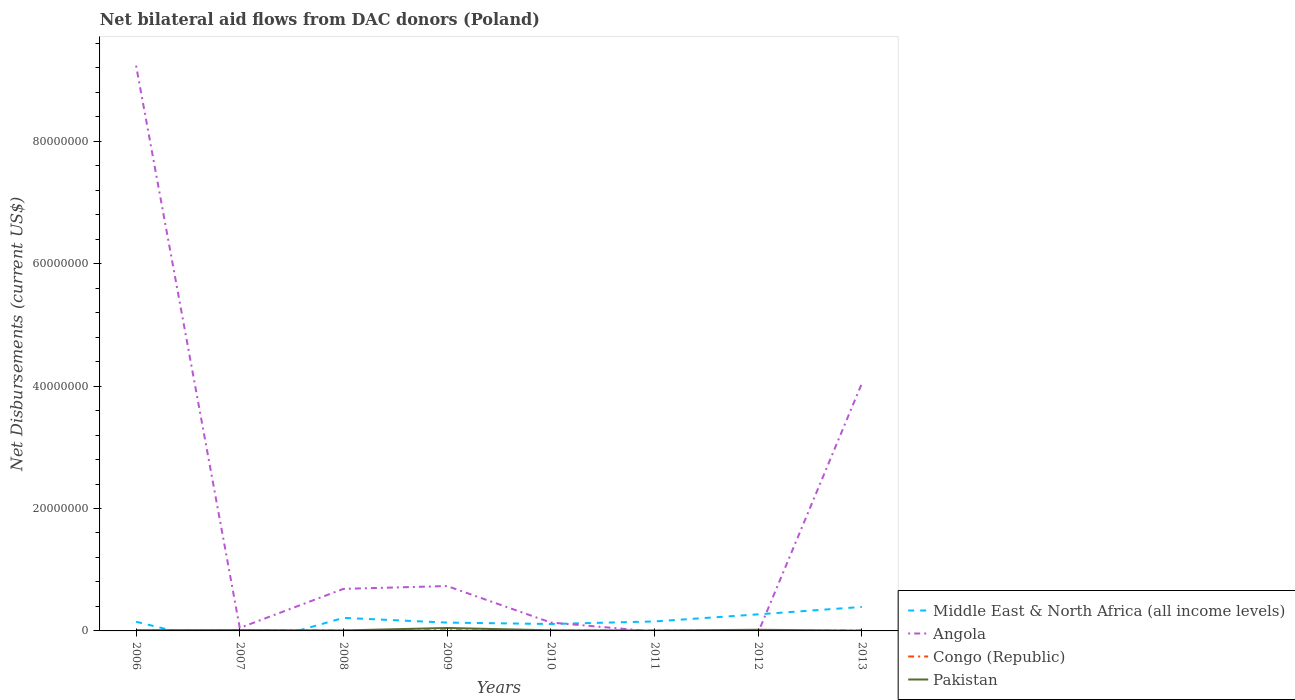What is the total net bilateral aid flows in Pakistan in the graph?
Your response must be concise. 1.00e+05. What is the difference between the highest and the second highest net bilateral aid flows in Middle East & North Africa (all income levels)?
Offer a terse response. 3.92e+06. What is the difference between the highest and the lowest net bilateral aid flows in Middle East & North Africa (all income levels)?
Ensure brevity in your answer.  3. How many lines are there?
Provide a short and direct response. 4. What is the difference between two consecutive major ticks on the Y-axis?
Offer a terse response. 2.00e+07. Are the values on the major ticks of Y-axis written in scientific E-notation?
Make the answer very short. No. Does the graph contain any zero values?
Give a very brief answer. Yes. Does the graph contain grids?
Keep it short and to the point. No. Where does the legend appear in the graph?
Offer a terse response. Bottom right. How are the legend labels stacked?
Offer a terse response. Vertical. What is the title of the graph?
Provide a short and direct response. Net bilateral aid flows from DAC donors (Poland). Does "India" appear as one of the legend labels in the graph?
Keep it short and to the point. No. What is the label or title of the Y-axis?
Your answer should be compact. Net Disbursements (current US$). What is the Net Disbursements (current US$) of Middle East & North Africa (all income levels) in 2006?
Keep it short and to the point. 1.50e+06. What is the Net Disbursements (current US$) of Angola in 2006?
Provide a succinct answer. 9.24e+07. What is the Net Disbursements (current US$) of Congo (Republic) in 2006?
Make the answer very short. 2.00e+04. What is the Net Disbursements (current US$) of Angola in 2007?
Offer a terse response. 4.90e+05. What is the Net Disbursements (current US$) in Pakistan in 2007?
Give a very brief answer. 1.40e+05. What is the Net Disbursements (current US$) in Middle East & North Africa (all income levels) in 2008?
Make the answer very short. 2.13e+06. What is the Net Disbursements (current US$) of Angola in 2008?
Keep it short and to the point. 6.87e+06. What is the Net Disbursements (current US$) of Pakistan in 2008?
Make the answer very short. 8.00e+04. What is the Net Disbursements (current US$) in Middle East & North Africa (all income levels) in 2009?
Offer a terse response. 1.36e+06. What is the Net Disbursements (current US$) of Angola in 2009?
Your response must be concise. 7.33e+06. What is the Net Disbursements (current US$) of Pakistan in 2009?
Offer a terse response. 4.80e+05. What is the Net Disbursements (current US$) of Middle East & North Africa (all income levels) in 2010?
Ensure brevity in your answer.  1.13e+06. What is the Net Disbursements (current US$) of Angola in 2010?
Your answer should be very brief. 1.37e+06. What is the Net Disbursements (current US$) in Pakistan in 2010?
Offer a terse response. 1.00e+05. What is the Net Disbursements (current US$) in Middle East & North Africa (all income levels) in 2011?
Keep it short and to the point. 1.55e+06. What is the Net Disbursements (current US$) in Angola in 2011?
Your answer should be very brief. 0. What is the Net Disbursements (current US$) of Congo (Republic) in 2011?
Offer a very short reply. 5.00e+04. What is the Net Disbursements (current US$) of Middle East & North Africa (all income levels) in 2012?
Keep it short and to the point. 2.71e+06. What is the Net Disbursements (current US$) in Pakistan in 2012?
Ensure brevity in your answer.  1.90e+05. What is the Net Disbursements (current US$) in Middle East & North Africa (all income levels) in 2013?
Offer a very short reply. 3.92e+06. What is the Net Disbursements (current US$) of Angola in 2013?
Make the answer very short. 4.04e+07. What is the Net Disbursements (current US$) in Congo (Republic) in 2013?
Provide a short and direct response. 6.00e+04. What is the Net Disbursements (current US$) in Pakistan in 2013?
Offer a terse response. 4.00e+04. Across all years, what is the maximum Net Disbursements (current US$) in Middle East & North Africa (all income levels)?
Your answer should be compact. 3.92e+06. Across all years, what is the maximum Net Disbursements (current US$) in Angola?
Ensure brevity in your answer.  9.24e+07. Across all years, what is the minimum Net Disbursements (current US$) in Pakistan?
Your answer should be very brief. 4.00e+04. What is the total Net Disbursements (current US$) of Middle East & North Africa (all income levels) in the graph?
Ensure brevity in your answer.  1.43e+07. What is the total Net Disbursements (current US$) of Angola in the graph?
Make the answer very short. 1.49e+08. What is the total Net Disbursements (current US$) in Pakistan in the graph?
Keep it short and to the point. 1.21e+06. What is the difference between the Net Disbursements (current US$) in Angola in 2006 and that in 2007?
Provide a succinct answer. 9.19e+07. What is the difference between the Net Disbursements (current US$) in Congo (Republic) in 2006 and that in 2007?
Provide a short and direct response. -9.00e+04. What is the difference between the Net Disbursements (current US$) in Middle East & North Africa (all income levels) in 2006 and that in 2008?
Your answer should be very brief. -6.30e+05. What is the difference between the Net Disbursements (current US$) in Angola in 2006 and that in 2008?
Give a very brief answer. 8.55e+07. What is the difference between the Net Disbursements (current US$) of Pakistan in 2006 and that in 2008?
Your response must be concise. 4.00e+04. What is the difference between the Net Disbursements (current US$) of Middle East & North Africa (all income levels) in 2006 and that in 2009?
Ensure brevity in your answer.  1.40e+05. What is the difference between the Net Disbursements (current US$) in Angola in 2006 and that in 2009?
Ensure brevity in your answer.  8.50e+07. What is the difference between the Net Disbursements (current US$) of Pakistan in 2006 and that in 2009?
Your answer should be compact. -3.60e+05. What is the difference between the Net Disbursements (current US$) in Angola in 2006 and that in 2010?
Make the answer very short. 9.10e+07. What is the difference between the Net Disbursements (current US$) in Pakistan in 2006 and that in 2010?
Provide a succinct answer. 2.00e+04. What is the difference between the Net Disbursements (current US$) of Middle East & North Africa (all income levels) in 2006 and that in 2011?
Provide a short and direct response. -5.00e+04. What is the difference between the Net Disbursements (current US$) of Congo (Republic) in 2006 and that in 2011?
Give a very brief answer. -3.00e+04. What is the difference between the Net Disbursements (current US$) of Pakistan in 2006 and that in 2011?
Your response must be concise. 6.00e+04. What is the difference between the Net Disbursements (current US$) in Middle East & North Africa (all income levels) in 2006 and that in 2012?
Offer a terse response. -1.21e+06. What is the difference between the Net Disbursements (current US$) in Pakistan in 2006 and that in 2012?
Give a very brief answer. -7.00e+04. What is the difference between the Net Disbursements (current US$) of Middle East & North Africa (all income levels) in 2006 and that in 2013?
Ensure brevity in your answer.  -2.42e+06. What is the difference between the Net Disbursements (current US$) of Angola in 2006 and that in 2013?
Make the answer very short. 5.19e+07. What is the difference between the Net Disbursements (current US$) in Congo (Republic) in 2006 and that in 2013?
Your response must be concise. -4.00e+04. What is the difference between the Net Disbursements (current US$) of Angola in 2007 and that in 2008?
Make the answer very short. -6.38e+06. What is the difference between the Net Disbursements (current US$) in Pakistan in 2007 and that in 2008?
Offer a very short reply. 6.00e+04. What is the difference between the Net Disbursements (current US$) in Angola in 2007 and that in 2009?
Make the answer very short. -6.84e+06. What is the difference between the Net Disbursements (current US$) of Pakistan in 2007 and that in 2009?
Ensure brevity in your answer.  -3.40e+05. What is the difference between the Net Disbursements (current US$) in Angola in 2007 and that in 2010?
Make the answer very short. -8.80e+05. What is the difference between the Net Disbursements (current US$) in Pakistan in 2007 and that in 2011?
Make the answer very short. 8.00e+04. What is the difference between the Net Disbursements (current US$) in Congo (Republic) in 2007 and that in 2012?
Give a very brief answer. 9.00e+04. What is the difference between the Net Disbursements (current US$) of Angola in 2007 and that in 2013?
Ensure brevity in your answer.  -4.00e+07. What is the difference between the Net Disbursements (current US$) in Congo (Republic) in 2007 and that in 2013?
Offer a very short reply. 5.00e+04. What is the difference between the Net Disbursements (current US$) of Middle East & North Africa (all income levels) in 2008 and that in 2009?
Ensure brevity in your answer.  7.70e+05. What is the difference between the Net Disbursements (current US$) of Angola in 2008 and that in 2009?
Offer a very short reply. -4.60e+05. What is the difference between the Net Disbursements (current US$) of Congo (Republic) in 2008 and that in 2009?
Provide a short and direct response. -6.00e+04. What is the difference between the Net Disbursements (current US$) of Pakistan in 2008 and that in 2009?
Provide a succinct answer. -4.00e+05. What is the difference between the Net Disbursements (current US$) of Middle East & North Africa (all income levels) in 2008 and that in 2010?
Your answer should be compact. 1.00e+06. What is the difference between the Net Disbursements (current US$) in Angola in 2008 and that in 2010?
Give a very brief answer. 5.50e+06. What is the difference between the Net Disbursements (current US$) in Congo (Republic) in 2008 and that in 2010?
Give a very brief answer. 10000. What is the difference between the Net Disbursements (current US$) in Middle East & North Africa (all income levels) in 2008 and that in 2011?
Your answer should be compact. 5.80e+05. What is the difference between the Net Disbursements (current US$) in Middle East & North Africa (all income levels) in 2008 and that in 2012?
Ensure brevity in your answer.  -5.80e+05. What is the difference between the Net Disbursements (current US$) in Congo (Republic) in 2008 and that in 2012?
Ensure brevity in your answer.  3.00e+04. What is the difference between the Net Disbursements (current US$) of Pakistan in 2008 and that in 2012?
Make the answer very short. -1.10e+05. What is the difference between the Net Disbursements (current US$) of Middle East & North Africa (all income levels) in 2008 and that in 2013?
Offer a very short reply. -1.79e+06. What is the difference between the Net Disbursements (current US$) in Angola in 2008 and that in 2013?
Give a very brief answer. -3.36e+07. What is the difference between the Net Disbursements (current US$) of Middle East & North Africa (all income levels) in 2009 and that in 2010?
Your answer should be compact. 2.30e+05. What is the difference between the Net Disbursements (current US$) of Angola in 2009 and that in 2010?
Offer a terse response. 5.96e+06. What is the difference between the Net Disbursements (current US$) in Pakistan in 2009 and that in 2010?
Provide a succinct answer. 3.80e+05. What is the difference between the Net Disbursements (current US$) of Middle East & North Africa (all income levels) in 2009 and that in 2012?
Offer a very short reply. -1.35e+06. What is the difference between the Net Disbursements (current US$) of Congo (Republic) in 2009 and that in 2012?
Your answer should be very brief. 9.00e+04. What is the difference between the Net Disbursements (current US$) of Pakistan in 2009 and that in 2012?
Make the answer very short. 2.90e+05. What is the difference between the Net Disbursements (current US$) in Middle East & North Africa (all income levels) in 2009 and that in 2013?
Your response must be concise. -2.56e+06. What is the difference between the Net Disbursements (current US$) in Angola in 2009 and that in 2013?
Give a very brief answer. -3.31e+07. What is the difference between the Net Disbursements (current US$) of Pakistan in 2009 and that in 2013?
Provide a short and direct response. 4.40e+05. What is the difference between the Net Disbursements (current US$) in Middle East & North Africa (all income levels) in 2010 and that in 2011?
Provide a succinct answer. -4.20e+05. What is the difference between the Net Disbursements (current US$) of Congo (Republic) in 2010 and that in 2011?
Provide a short and direct response. -10000. What is the difference between the Net Disbursements (current US$) of Pakistan in 2010 and that in 2011?
Offer a very short reply. 4.00e+04. What is the difference between the Net Disbursements (current US$) of Middle East & North Africa (all income levels) in 2010 and that in 2012?
Offer a terse response. -1.58e+06. What is the difference between the Net Disbursements (current US$) in Congo (Republic) in 2010 and that in 2012?
Make the answer very short. 2.00e+04. What is the difference between the Net Disbursements (current US$) of Pakistan in 2010 and that in 2012?
Provide a short and direct response. -9.00e+04. What is the difference between the Net Disbursements (current US$) of Middle East & North Africa (all income levels) in 2010 and that in 2013?
Give a very brief answer. -2.79e+06. What is the difference between the Net Disbursements (current US$) in Angola in 2010 and that in 2013?
Offer a terse response. -3.91e+07. What is the difference between the Net Disbursements (current US$) of Congo (Republic) in 2010 and that in 2013?
Your answer should be very brief. -2.00e+04. What is the difference between the Net Disbursements (current US$) of Pakistan in 2010 and that in 2013?
Your answer should be compact. 6.00e+04. What is the difference between the Net Disbursements (current US$) in Middle East & North Africa (all income levels) in 2011 and that in 2012?
Your answer should be compact. -1.16e+06. What is the difference between the Net Disbursements (current US$) of Congo (Republic) in 2011 and that in 2012?
Your answer should be compact. 3.00e+04. What is the difference between the Net Disbursements (current US$) of Pakistan in 2011 and that in 2012?
Offer a very short reply. -1.30e+05. What is the difference between the Net Disbursements (current US$) of Middle East & North Africa (all income levels) in 2011 and that in 2013?
Give a very brief answer. -2.37e+06. What is the difference between the Net Disbursements (current US$) in Pakistan in 2011 and that in 2013?
Provide a succinct answer. 2.00e+04. What is the difference between the Net Disbursements (current US$) in Middle East & North Africa (all income levels) in 2012 and that in 2013?
Your answer should be very brief. -1.21e+06. What is the difference between the Net Disbursements (current US$) in Congo (Republic) in 2012 and that in 2013?
Your answer should be very brief. -4.00e+04. What is the difference between the Net Disbursements (current US$) of Middle East & North Africa (all income levels) in 2006 and the Net Disbursements (current US$) of Angola in 2007?
Provide a succinct answer. 1.01e+06. What is the difference between the Net Disbursements (current US$) of Middle East & North Africa (all income levels) in 2006 and the Net Disbursements (current US$) of Congo (Republic) in 2007?
Provide a short and direct response. 1.39e+06. What is the difference between the Net Disbursements (current US$) of Middle East & North Africa (all income levels) in 2006 and the Net Disbursements (current US$) of Pakistan in 2007?
Your answer should be compact. 1.36e+06. What is the difference between the Net Disbursements (current US$) of Angola in 2006 and the Net Disbursements (current US$) of Congo (Republic) in 2007?
Your answer should be compact. 9.22e+07. What is the difference between the Net Disbursements (current US$) in Angola in 2006 and the Net Disbursements (current US$) in Pakistan in 2007?
Your response must be concise. 9.22e+07. What is the difference between the Net Disbursements (current US$) in Congo (Republic) in 2006 and the Net Disbursements (current US$) in Pakistan in 2007?
Your answer should be compact. -1.20e+05. What is the difference between the Net Disbursements (current US$) of Middle East & North Africa (all income levels) in 2006 and the Net Disbursements (current US$) of Angola in 2008?
Your response must be concise. -5.37e+06. What is the difference between the Net Disbursements (current US$) in Middle East & North Africa (all income levels) in 2006 and the Net Disbursements (current US$) in Congo (Republic) in 2008?
Your answer should be very brief. 1.45e+06. What is the difference between the Net Disbursements (current US$) in Middle East & North Africa (all income levels) in 2006 and the Net Disbursements (current US$) in Pakistan in 2008?
Your response must be concise. 1.42e+06. What is the difference between the Net Disbursements (current US$) in Angola in 2006 and the Net Disbursements (current US$) in Congo (Republic) in 2008?
Provide a succinct answer. 9.23e+07. What is the difference between the Net Disbursements (current US$) of Angola in 2006 and the Net Disbursements (current US$) of Pakistan in 2008?
Your response must be concise. 9.23e+07. What is the difference between the Net Disbursements (current US$) in Middle East & North Africa (all income levels) in 2006 and the Net Disbursements (current US$) in Angola in 2009?
Your answer should be compact. -5.83e+06. What is the difference between the Net Disbursements (current US$) in Middle East & North Africa (all income levels) in 2006 and the Net Disbursements (current US$) in Congo (Republic) in 2009?
Offer a terse response. 1.39e+06. What is the difference between the Net Disbursements (current US$) in Middle East & North Africa (all income levels) in 2006 and the Net Disbursements (current US$) in Pakistan in 2009?
Provide a succinct answer. 1.02e+06. What is the difference between the Net Disbursements (current US$) of Angola in 2006 and the Net Disbursements (current US$) of Congo (Republic) in 2009?
Ensure brevity in your answer.  9.22e+07. What is the difference between the Net Disbursements (current US$) of Angola in 2006 and the Net Disbursements (current US$) of Pakistan in 2009?
Keep it short and to the point. 9.19e+07. What is the difference between the Net Disbursements (current US$) in Congo (Republic) in 2006 and the Net Disbursements (current US$) in Pakistan in 2009?
Offer a terse response. -4.60e+05. What is the difference between the Net Disbursements (current US$) of Middle East & North Africa (all income levels) in 2006 and the Net Disbursements (current US$) of Angola in 2010?
Your answer should be very brief. 1.30e+05. What is the difference between the Net Disbursements (current US$) of Middle East & North Africa (all income levels) in 2006 and the Net Disbursements (current US$) of Congo (Republic) in 2010?
Your response must be concise. 1.46e+06. What is the difference between the Net Disbursements (current US$) of Middle East & North Africa (all income levels) in 2006 and the Net Disbursements (current US$) of Pakistan in 2010?
Your response must be concise. 1.40e+06. What is the difference between the Net Disbursements (current US$) of Angola in 2006 and the Net Disbursements (current US$) of Congo (Republic) in 2010?
Provide a short and direct response. 9.23e+07. What is the difference between the Net Disbursements (current US$) of Angola in 2006 and the Net Disbursements (current US$) of Pakistan in 2010?
Keep it short and to the point. 9.22e+07. What is the difference between the Net Disbursements (current US$) of Congo (Republic) in 2006 and the Net Disbursements (current US$) of Pakistan in 2010?
Make the answer very short. -8.00e+04. What is the difference between the Net Disbursements (current US$) of Middle East & North Africa (all income levels) in 2006 and the Net Disbursements (current US$) of Congo (Republic) in 2011?
Offer a very short reply. 1.45e+06. What is the difference between the Net Disbursements (current US$) of Middle East & North Africa (all income levels) in 2006 and the Net Disbursements (current US$) of Pakistan in 2011?
Ensure brevity in your answer.  1.44e+06. What is the difference between the Net Disbursements (current US$) in Angola in 2006 and the Net Disbursements (current US$) in Congo (Republic) in 2011?
Your answer should be compact. 9.23e+07. What is the difference between the Net Disbursements (current US$) of Angola in 2006 and the Net Disbursements (current US$) of Pakistan in 2011?
Provide a short and direct response. 9.23e+07. What is the difference between the Net Disbursements (current US$) of Congo (Republic) in 2006 and the Net Disbursements (current US$) of Pakistan in 2011?
Keep it short and to the point. -4.00e+04. What is the difference between the Net Disbursements (current US$) in Middle East & North Africa (all income levels) in 2006 and the Net Disbursements (current US$) in Congo (Republic) in 2012?
Offer a very short reply. 1.48e+06. What is the difference between the Net Disbursements (current US$) in Middle East & North Africa (all income levels) in 2006 and the Net Disbursements (current US$) in Pakistan in 2012?
Keep it short and to the point. 1.31e+06. What is the difference between the Net Disbursements (current US$) of Angola in 2006 and the Net Disbursements (current US$) of Congo (Republic) in 2012?
Your answer should be compact. 9.23e+07. What is the difference between the Net Disbursements (current US$) in Angola in 2006 and the Net Disbursements (current US$) in Pakistan in 2012?
Ensure brevity in your answer.  9.22e+07. What is the difference between the Net Disbursements (current US$) of Middle East & North Africa (all income levels) in 2006 and the Net Disbursements (current US$) of Angola in 2013?
Keep it short and to the point. -3.89e+07. What is the difference between the Net Disbursements (current US$) in Middle East & North Africa (all income levels) in 2006 and the Net Disbursements (current US$) in Congo (Republic) in 2013?
Your response must be concise. 1.44e+06. What is the difference between the Net Disbursements (current US$) of Middle East & North Africa (all income levels) in 2006 and the Net Disbursements (current US$) of Pakistan in 2013?
Your response must be concise. 1.46e+06. What is the difference between the Net Disbursements (current US$) in Angola in 2006 and the Net Disbursements (current US$) in Congo (Republic) in 2013?
Provide a succinct answer. 9.23e+07. What is the difference between the Net Disbursements (current US$) of Angola in 2006 and the Net Disbursements (current US$) of Pakistan in 2013?
Give a very brief answer. 9.23e+07. What is the difference between the Net Disbursements (current US$) in Angola in 2007 and the Net Disbursements (current US$) in Congo (Republic) in 2008?
Your response must be concise. 4.40e+05. What is the difference between the Net Disbursements (current US$) of Angola in 2007 and the Net Disbursements (current US$) of Congo (Republic) in 2009?
Your answer should be compact. 3.80e+05. What is the difference between the Net Disbursements (current US$) in Angola in 2007 and the Net Disbursements (current US$) in Pakistan in 2009?
Provide a succinct answer. 10000. What is the difference between the Net Disbursements (current US$) in Congo (Republic) in 2007 and the Net Disbursements (current US$) in Pakistan in 2009?
Keep it short and to the point. -3.70e+05. What is the difference between the Net Disbursements (current US$) in Congo (Republic) in 2007 and the Net Disbursements (current US$) in Pakistan in 2010?
Your response must be concise. 10000. What is the difference between the Net Disbursements (current US$) in Congo (Republic) in 2007 and the Net Disbursements (current US$) in Pakistan in 2011?
Provide a succinct answer. 5.00e+04. What is the difference between the Net Disbursements (current US$) in Angola in 2007 and the Net Disbursements (current US$) in Congo (Republic) in 2012?
Make the answer very short. 4.70e+05. What is the difference between the Net Disbursements (current US$) in Angola in 2007 and the Net Disbursements (current US$) in Pakistan in 2012?
Keep it short and to the point. 3.00e+05. What is the difference between the Net Disbursements (current US$) in Angola in 2007 and the Net Disbursements (current US$) in Congo (Republic) in 2013?
Your response must be concise. 4.30e+05. What is the difference between the Net Disbursements (current US$) of Middle East & North Africa (all income levels) in 2008 and the Net Disbursements (current US$) of Angola in 2009?
Your answer should be compact. -5.20e+06. What is the difference between the Net Disbursements (current US$) of Middle East & North Africa (all income levels) in 2008 and the Net Disbursements (current US$) of Congo (Republic) in 2009?
Your response must be concise. 2.02e+06. What is the difference between the Net Disbursements (current US$) of Middle East & North Africa (all income levels) in 2008 and the Net Disbursements (current US$) of Pakistan in 2009?
Offer a terse response. 1.65e+06. What is the difference between the Net Disbursements (current US$) in Angola in 2008 and the Net Disbursements (current US$) in Congo (Republic) in 2009?
Give a very brief answer. 6.76e+06. What is the difference between the Net Disbursements (current US$) in Angola in 2008 and the Net Disbursements (current US$) in Pakistan in 2009?
Offer a terse response. 6.39e+06. What is the difference between the Net Disbursements (current US$) in Congo (Republic) in 2008 and the Net Disbursements (current US$) in Pakistan in 2009?
Your answer should be compact. -4.30e+05. What is the difference between the Net Disbursements (current US$) in Middle East & North Africa (all income levels) in 2008 and the Net Disbursements (current US$) in Angola in 2010?
Your answer should be very brief. 7.60e+05. What is the difference between the Net Disbursements (current US$) in Middle East & North Africa (all income levels) in 2008 and the Net Disbursements (current US$) in Congo (Republic) in 2010?
Offer a terse response. 2.09e+06. What is the difference between the Net Disbursements (current US$) in Middle East & North Africa (all income levels) in 2008 and the Net Disbursements (current US$) in Pakistan in 2010?
Make the answer very short. 2.03e+06. What is the difference between the Net Disbursements (current US$) of Angola in 2008 and the Net Disbursements (current US$) of Congo (Republic) in 2010?
Your response must be concise. 6.83e+06. What is the difference between the Net Disbursements (current US$) in Angola in 2008 and the Net Disbursements (current US$) in Pakistan in 2010?
Your response must be concise. 6.77e+06. What is the difference between the Net Disbursements (current US$) of Middle East & North Africa (all income levels) in 2008 and the Net Disbursements (current US$) of Congo (Republic) in 2011?
Make the answer very short. 2.08e+06. What is the difference between the Net Disbursements (current US$) of Middle East & North Africa (all income levels) in 2008 and the Net Disbursements (current US$) of Pakistan in 2011?
Offer a terse response. 2.07e+06. What is the difference between the Net Disbursements (current US$) of Angola in 2008 and the Net Disbursements (current US$) of Congo (Republic) in 2011?
Give a very brief answer. 6.82e+06. What is the difference between the Net Disbursements (current US$) of Angola in 2008 and the Net Disbursements (current US$) of Pakistan in 2011?
Offer a very short reply. 6.81e+06. What is the difference between the Net Disbursements (current US$) in Middle East & North Africa (all income levels) in 2008 and the Net Disbursements (current US$) in Congo (Republic) in 2012?
Keep it short and to the point. 2.11e+06. What is the difference between the Net Disbursements (current US$) in Middle East & North Africa (all income levels) in 2008 and the Net Disbursements (current US$) in Pakistan in 2012?
Offer a terse response. 1.94e+06. What is the difference between the Net Disbursements (current US$) of Angola in 2008 and the Net Disbursements (current US$) of Congo (Republic) in 2012?
Your answer should be very brief. 6.85e+06. What is the difference between the Net Disbursements (current US$) in Angola in 2008 and the Net Disbursements (current US$) in Pakistan in 2012?
Provide a succinct answer. 6.68e+06. What is the difference between the Net Disbursements (current US$) in Middle East & North Africa (all income levels) in 2008 and the Net Disbursements (current US$) in Angola in 2013?
Make the answer very short. -3.83e+07. What is the difference between the Net Disbursements (current US$) of Middle East & North Africa (all income levels) in 2008 and the Net Disbursements (current US$) of Congo (Republic) in 2013?
Make the answer very short. 2.07e+06. What is the difference between the Net Disbursements (current US$) of Middle East & North Africa (all income levels) in 2008 and the Net Disbursements (current US$) of Pakistan in 2013?
Offer a terse response. 2.09e+06. What is the difference between the Net Disbursements (current US$) in Angola in 2008 and the Net Disbursements (current US$) in Congo (Republic) in 2013?
Make the answer very short. 6.81e+06. What is the difference between the Net Disbursements (current US$) of Angola in 2008 and the Net Disbursements (current US$) of Pakistan in 2013?
Provide a succinct answer. 6.83e+06. What is the difference between the Net Disbursements (current US$) in Congo (Republic) in 2008 and the Net Disbursements (current US$) in Pakistan in 2013?
Ensure brevity in your answer.  10000. What is the difference between the Net Disbursements (current US$) of Middle East & North Africa (all income levels) in 2009 and the Net Disbursements (current US$) of Angola in 2010?
Ensure brevity in your answer.  -10000. What is the difference between the Net Disbursements (current US$) of Middle East & North Africa (all income levels) in 2009 and the Net Disbursements (current US$) of Congo (Republic) in 2010?
Provide a short and direct response. 1.32e+06. What is the difference between the Net Disbursements (current US$) in Middle East & North Africa (all income levels) in 2009 and the Net Disbursements (current US$) in Pakistan in 2010?
Offer a terse response. 1.26e+06. What is the difference between the Net Disbursements (current US$) of Angola in 2009 and the Net Disbursements (current US$) of Congo (Republic) in 2010?
Your response must be concise. 7.29e+06. What is the difference between the Net Disbursements (current US$) in Angola in 2009 and the Net Disbursements (current US$) in Pakistan in 2010?
Give a very brief answer. 7.23e+06. What is the difference between the Net Disbursements (current US$) in Congo (Republic) in 2009 and the Net Disbursements (current US$) in Pakistan in 2010?
Keep it short and to the point. 10000. What is the difference between the Net Disbursements (current US$) in Middle East & North Africa (all income levels) in 2009 and the Net Disbursements (current US$) in Congo (Republic) in 2011?
Provide a short and direct response. 1.31e+06. What is the difference between the Net Disbursements (current US$) of Middle East & North Africa (all income levels) in 2009 and the Net Disbursements (current US$) of Pakistan in 2011?
Make the answer very short. 1.30e+06. What is the difference between the Net Disbursements (current US$) in Angola in 2009 and the Net Disbursements (current US$) in Congo (Republic) in 2011?
Your answer should be very brief. 7.28e+06. What is the difference between the Net Disbursements (current US$) of Angola in 2009 and the Net Disbursements (current US$) of Pakistan in 2011?
Keep it short and to the point. 7.27e+06. What is the difference between the Net Disbursements (current US$) of Middle East & North Africa (all income levels) in 2009 and the Net Disbursements (current US$) of Congo (Republic) in 2012?
Your answer should be very brief. 1.34e+06. What is the difference between the Net Disbursements (current US$) of Middle East & North Africa (all income levels) in 2009 and the Net Disbursements (current US$) of Pakistan in 2012?
Ensure brevity in your answer.  1.17e+06. What is the difference between the Net Disbursements (current US$) in Angola in 2009 and the Net Disbursements (current US$) in Congo (Republic) in 2012?
Your response must be concise. 7.31e+06. What is the difference between the Net Disbursements (current US$) of Angola in 2009 and the Net Disbursements (current US$) of Pakistan in 2012?
Your answer should be compact. 7.14e+06. What is the difference between the Net Disbursements (current US$) in Middle East & North Africa (all income levels) in 2009 and the Net Disbursements (current US$) in Angola in 2013?
Keep it short and to the point. -3.91e+07. What is the difference between the Net Disbursements (current US$) of Middle East & North Africa (all income levels) in 2009 and the Net Disbursements (current US$) of Congo (Republic) in 2013?
Your answer should be compact. 1.30e+06. What is the difference between the Net Disbursements (current US$) in Middle East & North Africa (all income levels) in 2009 and the Net Disbursements (current US$) in Pakistan in 2013?
Make the answer very short. 1.32e+06. What is the difference between the Net Disbursements (current US$) in Angola in 2009 and the Net Disbursements (current US$) in Congo (Republic) in 2013?
Keep it short and to the point. 7.27e+06. What is the difference between the Net Disbursements (current US$) in Angola in 2009 and the Net Disbursements (current US$) in Pakistan in 2013?
Make the answer very short. 7.29e+06. What is the difference between the Net Disbursements (current US$) of Middle East & North Africa (all income levels) in 2010 and the Net Disbursements (current US$) of Congo (Republic) in 2011?
Make the answer very short. 1.08e+06. What is the difference between the Net Disbursements (current US$) in Middle East & North Africa (all income levels) in 2010 and the Net Disbursements (current US$) in Pakistan in 2011?
Keep it short and to the point. 1.07e+06. What is the difference between the Net Disbursements (current US$) of Angola in 2010 and the Net Disbursements (current US$) of Congo (Republic) in 2011?
Provide a succinct answer. 1.32e+06. What is the difference between the Net Disbursements (current US$) in Angola in 2010 and the Net Disbursements (current US$) in Pakistan in 2011?
Offer a terse response. 1.31e+06. What is the difference between the Net Disbursements (current US$) in Middle East & North Africa (all income levels) in 2010 and the Net Disbursements (current US$) in Congo (Republic) in 2012?
Your answer should be very brief. 1.11e+06. What is the difference between the Net Disbursements (current US$) of Middle East & North Africa (all income levels) in 2010 and the Net Disbursements (current US$) of Pakistan in 2012?
Provide a short and direct response. 9.40e+05. What is the difference between the Net Disbursements (current US$) of Angola in 2010 and the Net Disbursements (current US$) of Congo (Republic) in 2012?
Provide a succinct answer. 1.35e+06. What is the difference between the Net Disbursements (current US$) of Angola in 2010 and the Net Disbursements (current US$) of Pakistan in 2012?
Give a very brief answer. 1.18e+06. What is the difference between the Net Disbursements (current US$) of Middle East & North Africa (all income levels) in 2010 and the Net Disbursements (current US$) of Angola in 2013?
Provide a succinct answer. -3.93e+07. What is the difference between the Net Disbursements (current US$) of Middle East & North Africa (all income levels) in 2010 and the Net Disbursements (current US$) of Congo (Republic) in 2013?
Your response must be concise. 1.07e+06. What is the difference between the Net Disbursements (current US$) of Middle East & North Africa (all income levels) in 2010 and the Net Disbursements (current US$) of Pakistan in 2013?
Ensure brevity in your answer.  1.09e+06. What is the difference between the Net Disbursements (current US$) in Angola in 2010 and the Net Disbursements (current US$) in Congo (Republic) in 2013?
Your response must be concise. 1.31e+06. What is the difference between the Net Disbursements (current US$) in Angola in 2010 and the Net Disbursements (current US$) in Pakistan in 2013?
Make the answer very short. 1.33e+06. What is the difference between the Net Disbursements (current US$) in Congo (Republic) in 2010 and the Net Disbursements (current US$) in Pakistan in 2013?
Provide a succinct answer. 0. What is the difference between the Net Disbursements (current US$) of Middle East & North Africa (all income levels) in 2011 and the Net Disbursements (current US$) of Congo (Republic) in 2012?
Ensure brevity in your answer.  1.53e+06. What is the difference between the Net Disbursements (current US$) in Middle East & North Africa (all income levels) in 2011 and the Net Disbursements (current US$) in Pakistan in 2012?
Provide a succinct answer. 1.36e+06. What is the difference between the Net Disbursements (current US$) of Middle East & North Africa (all income levels) in 2011 and the Net Disbursements (current US$) of Angola in 2013?
Your answer should be compact. -3.89e+07. What is the difference between the Net Disbursements (current US$) of Middle East & North Africa (all income levels) in 2011 and the Net Disbursements (current US$) of Congo (Republic) in 2013?
Offer a terse response. 1.49e+06. What is the difference between the Net Disbursements (current US$) in Middle East & North Africa (all income levels) in 2011 and the Net Disbursements (current US$) in Pakistan in 2013?
Ensure brevity in your answer.  1.51e+06. What is the difference between the Net Disbursements (current US$) of Middle East & North Africa (all income levels) in 2012 and the Net Disbursements (current US$) of Angola in 2013?
Offer a terse response. -3.77e+07. What is the difference between the Net Disbursements (current US$) of Middle East & North Africa (all income levels) in 2012 and the Net Disbursements (current US$) of Congo (Republic) in 2013?
Provide a succinct answer. 2.65e+06. What is the difference between the Net Disbursements (current US$) in Middle East & North Africa (all income levels) in 2012 and the Net Disbursements (current US$) in Pakistan in 2013?
Make the answer very short. 2.67e+06. What is the difference between the Net Disbursements (current US$) in Congo (Republic) in 2012 and the Net Disbursements (current US$) in Pakistan in 2013?
Provide a succinct answer. -2.00e+04. What is the average Net Disbursements (current US$) of Middle East & North Africa (all income levels) per year?
Provide a short and direct response. 1.79e+06. What is the average Net Disbursements (current US$) in Angola per year?
Your response must be concise. 1.86e+07. What is the average Net Disbursements (current US$) in Congo (Republic) per year?
Provide a short and direct response. 5.75e+04. What is the average Net Disbursements (current US$) in Pakistan per year?
Provide a short and direct response. 1.51e+05. In the year 2006, what is the difference between the Net Disbursements (current US$) of Middle East & North Africa (all income levels) and Net Disbursements (current US$) of Angola?
Provide a short and direct response. -9.08e+07. In the year 2006, what is the difference between the Net Disbursements (current US$) of Middle East & North Africa (all income levels) and Net Disbursements (current US$) of Congo (Republic)?
Make the answer very short. 1.48e+06. In the year 2006, what is the difference between the Net Disbursements (current US$) of Middle East & North Africa (all income levels) and Net Disbursements (current US$) of Pakistan?
Make the answer very short. 1.38e+06. In the year 2006, what is the difference between the Net Disbursements (current US$) in Angola and Net Disbursements (current US$) in Congo (Republic)?
Give a very brief answer. 9.23e+07. In the year 2006, what is the difference between the Net Disbursements (current US$) in Angola and Net Disbursements (current US$) in Pakistan?
Keep it short and to the point. 9.22e+07. In the year 2007, what is the difference between the Net Disbursements (current US$) of Angola and Net Disbursements (current US$) of Congo (Republic)?
Provide a succinct answer. 3.80e+05. In the year 2007, what is the difference between the Net Disbursements (current US$) in Angola and Net Disbursements (current US$) in Pakistan?
Your answer should be very brief. 3.50e+05. In the year 2008, what is the difference between the Net Disbursements (current US$) of Middle East & North Africa (all income levels) and Net Disbursements (current US$) of Angola?
Your answer should be very brief. -4.74e+06. In the year 2008, what is the difference between the Net Disbursements (current US$) of Middle East & North Africa (all income levels) and Net Disbursements (current US$) of Congo (Republic)?
Your answer should be very brief. 2.08e+06. In the year 2008, what is the difference between the Net Disbursements (current US$) of Middle East & North Africa (all income levels) and Net Disbursements (current US$) of Pakistan?
Provide a short and direct response. 2.05e+06. In the year 2008, what is the difference between the Net Disbursements (current US$) in Angola and Net Disbursements (current US$) in Congo (Republic)?
Keep it short and to the point. 6.82e+06. In the year 2008, what is the difference between the Net Disbursements (current US$) of Angola and Net Disbursements (current US$) of Pakistan?
Your answer should be very brief. 6.79e+06. In the year 2009, what is the difference between the Net Disbursements (current US$) in Middle East & North Africa (all income levels) and Net Disbursements (current US$) in Angola?
Give a very brief answer. -5.97e+06. In the year 2009, what is the difference between the Net Disbursements (current US$) in Middle East & North Africa (all income levels) and Net Disbursements (current US$) in Congo (Republic)?
Your response must be concise. 1.25e+06. In the year 2009, what is the difference between the Net Disbursements (current US$) of Middle East & North Africa (all income levels) and Net Disbursements (current US$) of Pakistan?
Offer a very short reply. 8.80e+05. In the year 2009, what is the difference between the Net Disbursements (current US$) in Angola and Net Disbursements (current US$) in Congo (Republic)?
Your response must be concise. 7.22e+06. In the year 2009, what is the difference between the Net Disbursements (current US$) in Angola and Net Disbursements (current US$) in Pakistan?
Offer a very short reply. 6.85e+06. In the year 2009, what is the difference between the Net Disbursements (current US$) in Congo (Republic) and Net Disbursements (current US$) in Pakistan?
Offer a very short reply. -3.70e+05. In the year 2010, what is the difference between the Net Disbursements (current US$) of Middle East & North Africa (all income levels) and Net Disbursements (current US$) of Angola?
Your response must be concise. -2.40e+05. In the year 2010, what is the difference between the Net Disbursements (current US$) in Middle East & North Africa (all income levels) and Net Disbursements (current US$) in Congo (Republic)?
Offer a very short reply. 1.09e+06. In the year 2010, what is the difference between the Net Disbursements (current US$) in Middle East & North Africa (all income levels) and Net Disbursements (current US$) in Pakistan?
Offer a very short reply. 1.03e+06. In the year 2010, what is the difference between the Net Disbursements (current US$) in Angola and Net Disbursements (current US$) in Congo (Republic)?
Give a very brief answer. 1.33e+06. In the year 2010, what is the difference between the Net Disbursements (current US$) of Angola and Net Disbursements (current US$) of Pakistan?
Give a very brief answer. 1.27e+06. In the year 2010, what is the difference between the Net Disbursements (current US$) of Congo (Republic) and Net Disbursements (current US$) of Pakistan?
Keep it short and to the point. -6.00e+04. In the year 2011, what is the difference between the Net Disbursements (current US$) of Middle East & North Africa (all income levels) and Net Disbursements (current US$) of Congo (Republic)?
Keep it short and to the point. 1.50e+06. In the year 2011, what is the difference between the Net Disbursements (current US$) in Middle East & North Africa (all income levels) and Net Disbursements (current US$) in Pakistan?
Provide a short and direct response. 1.49e+06. In the year 2011, what is the difference between the Net Disbursements (current US$) in Congo (Republic) and Net Disbursements (current US$) in Pakistan?
Give a very brief answer. -10000. In the year 2012, what is the difference between the Net Disbursements (current US$) of Middle East & North Africa (all income levels) and Net Disbursements (current US$) of Congo (Republic)?
Provide a short and direct response. 2.69e+06. In the year 2012, what is the difference between the Net Disbursements (current US$) in Middle East & North Africa (all income levels) and Net Disbursements (current US$) in Pakistan?
Ensure brevity in your answer.  2.52e+06. In the year 2013, what is the difference between the Net Disbursements (current US$) of Middle East & North Africa (all income levels) and Net Disbursements (current US$) of Angola?
Provide a short and direct response. -3.65e+07. In the year 2013, what is the difference between the Net Disbursements (current US$) of Middle East & North Africa (all income levels) and Net Disbursements (current US$) of Congo (Republic)?
Make the answer very short. 3.86e+06. In the year 2013, what is the difference between the Net Disbursements (current US$) of Middle East & North Africa (all income levels) and Net Disbursements (current US$) of Pakistan?
Offer a very short reply. 3.88e+06. In the year 2013, what is the difference between the Net Disbursements (current US$) in Angola and Net Disbursements (current US$) in Congo (Republic)?
Ensure brevity in your answer.  4.04e+07. In the year 2013, what is the difference between the Net Disbursements (current US$) of Angola and Net Disbursements (current US$) of Pakistan?
Keep it short and to the point. 4.04e+07. In the year 2013, what is the difference between the Net Disbursements (current US$) in Congo (Republic) and Net Disbursements (current US$) in Pakistan?
Your answer should be compact. 2.00e+04. What is the ratio of the Net Disbursements (current US$) in Angola in 2006 to that in 2007?
Provide a short and direct response. 188.47. What is the ratio of the Net Disbursements (current US$) of Congo (Republic) in 2006 to that in 2007?
Offer a terse response. 0.18. What is the ratio of the Net Disbursements (current US$) of Pakistan in 2006 to that in 2007?
Your answer should be compact. 0.86. What is the ratio of the Net Disbursements (current US$) in Middle East & North Africa (all income levels) in 2006 to that in 2008?
Provide a succinct answer. 0.7. What is the ratio of the Net Disbursements (current US$) of Angola in 2006 to that in 2008?
Provide a short and direct response. 13.44. What is the ratio of the Net Disbursements (current US$) of Congo (Republic) in 2006 to that in 2008?
Offer a terse response. 0.4. What is the ratio of the Net Disbursements (current US$) in Middle East & North Africa (all income levels) in 2006 to that in 2009?
Keep it short and to the point. 1.1. What is the ratio of the Net Disbursements (current US$) of Angola in 2006 to that in 2009?
Provide a short and direct response. 12.6. What is the ratio of the Net Disbursements (current US$) of Congo (Republic) in 2006 to that in 2009?
Your answer should be very brief. 0.18. What is the ratio of the Net Disbursements (current US$) in Pakistan in 2006 to that in 2009?
Offer a terse response. 0.25. What is the ratio of the Net Disbursements (current US$) in Middle East & North Africa (all income levels) in 2006 to that in 2010?
Keep it short and to the point. 1.33. What is the ratio of the Net Disbursements (current US$) in Angola in 2006 to that in 2010?
Give a very brief answer. 67.41. What is the ratio of the Net Disbursements (current US$) in Middle East & North Africa (all income levels) in 2006 to that in 2011?
Provide a short and direct response. 0.97. What is the ratio of the Net Disbursements (current US$) in Congo (Republic) in 2006 to that in 2011?
Provide a short and direct response. 0.4. What is the ratio of the Net Disbursements (current US$) in Pakistan in 2006 to that in 2011?
Ensure brevity in your answer.  2. What is the ratio of the Net Disbursements (current US$) of Middle East & North Africa (all income levels) in 2006 to that in 2012?
Your answer should be compact. 0.55. What is the ratio of the Net Disbursements (current US$) in Pakistan in 2006 to that in 2012?
Provide a succinct answer. 0.63. What is the ratio of the Net Disbursements (current US$) of Middle East & North Africa (all income levels) in 2006 to that in 2013?
Your answer should be compact. 0.38. What is the ratio of the Net Disbursements (current US$) of Angola in 2006 to that in 2013?
Your answer should be compact. 2.28. What is the ratio of the Net Disbursements (current US$) in Congo (Republic) in 2006 to that in 2013?
Your response must be concise. 0.33. What is the ratio of the Net Disbursements (current US$) of Pakistan in 2006 to that in 2013?
Offer a very short reply. 3. What is the ratio of the Net Disbursements (current US$) of Angola in 2007 to that in 2008?
Give a very brief answer. 0.07. What is the ratio of the Net Disbursements (current US$) in Angola in 2007 to that in 2009?
Give a very brief answer. 0.07. What is the ratio of the Net Disbursements (current US$) in Congo (Republic) in 2007 to that in 2009?
Provide a succinct answer. 1. What is the ratio of the Net Disbursements (current US$) in Pakistan in 2007 to that in 2009?
Offer a terse response. 0.29. What is the ratio of the Net Disbursements (current US$) of Angola in 2007 to that in 2010?
Your response must be concise. 0.36. What is the ratio of the Net Disbursements (current US$) of Congo (Republic) in 2007 to that in 2010?
Ensure brevity in your answer.  2.75. What is the ratio of the Net Disbursements (current US$) of Congo (Republic) in 2007 to that in 2011?
Your answer should be compact. 2.2. What is the ratio of the Net Disbursements (current US$) in Pakistan in 2007 to that in 2011?
Your answer should be compact. 2.33. What is the ratio of the Net Disbursements (current US$) of Pakistan in 2007 to that in 2012?
Give a very brief answer. 0.74. What is the ratio of the Net Disbursements (current US$) of Angola in 2007 to that in 2013?
Your response must be concise. 0.01. What is the ratio of the Net Disbursements (current US$) of Congo (Republic) in 2007 to that in 2013?
Give a very brief answer. 1.83. What is the ratio of the Net Disbursements (current US$) of Middle East & North Africa (all income levels) in 2008 to that in 2009?
Offer a very short reply. 1.57. What is the ratio of the Net Disbursements (current US$) in Angola in 2008 to that in 2009?
Your answer should be compact. 0.94. What is the ratio of the Net Disbursements (current US$) of Congo (Republic) in 2008 to that in 2009?
Keep it short and to the point. 0.45. What is the ratio of the Net Disbursements (current US$) in Pakistan in 2008 to that in 2009?
Provide a succinct answer. 0.17. What is the ratio of the Net Disbursements (current US$) in Middle East & North Africa (all income levels) in 2008 to that in 2010?
Keep it short and to the point. 1.89. What is the ratio of the Net Disbursements (current US$) in Angola in 2008 to that in 2010?
Ensure brevity in your answer.  5.01. What is the ratio of the Net Disbursements (current US$) of Pakistan in 2008 to that in 2010?
Keep it short and to the point. 0.8. What is the ratio of the Net Disbursements (current US$) of Middle East & North Africa (all income levels) in 2008 to that in 2011?
Offer a very short reply. 1.37. What is the ratio of the Net Disbursements (current US$) of Congo (Republic) in 2008 to that in 2011?
Make the answer very short. 1. What is the ratio of the Net Disbursements (current US$) of Middle East & North Africa (all income levels) in 2008 to that in 2012?
Keep it short and to the point. 0.79. What is the ratio of the Net Disbursements (current US$) in Pakistan in 2008 to that in 2012?
Ensure brevity in your answer.  0.42. What is the ratio of the Net Disbursements (current US$) of Middle East & North Africa (all income levels) in 2008 to that in 2013?
Your answer should be very brief. 0.54. What is the ratio of the Net Disbursements (current US$) of Angola in 2008 to that in 2013?
Ensure brevity in your answer.  0.17. What is the ratio of the Net Disbursements (current US$) of Middle East & North Africa (all income levels) in 2009 to that in 2010?
Ensure brevity in your answer.  1.2. What is the ratio of the Net Disbursements (current US$) of Angola in 2009 to that in 2010?
Your answer should be compact. 5.35. What is the ratio of the Net Disbursements (current US$) in Congo (Republic) in 2009 to that in 2010?
Provide a short and direct response. 2.75. What is the ratio of the Net Disbursements (current US$) in Middle East & North Africa (all income levels) in 2009 to that in 2011?
Give a very brief answer. 0.88. What is the ratio of the Net Disbursements (current US$) in Pakistan in 2009 to that in 2011?
Your response must be concise. 8. What is the ratio of the Net Disbursements (current US$) in Middle East & North Africa (all income levels) in 2009 to that in 2012?
Give a very brief answer. 0.5. What is the ratio of the Net Disbursements (current US$) of Pakistan in 2009 to that in 2012?
Offer a terse response. 2.53. What is the ratio of the Net Disbursements (current US$) of Middle East & North Africa (all income levels) in 2009 to that in 2013?
Give a very brief answer. 0.35. What is the ratio of the Net Disbursements (current US$) in Angola in 2009 to that in 2013?
Keep it short and to the point. 0.18. What is the ratio of the Net Disbursements (current US$) in Congo (Republic) in 2009 to that in 2013?
Provide a succinct answer. 1.83. What is the ratio of the Net Disbursements (current US$) in Pakistan in 2009 to that in 2013?
Keep it short and to the point. 12. What is the ratio of the Net Disbursements (current US$) of Middle East & North Africa (all income levels) in 2010 to that in 2011?
Your response must be concise. 0.73. What is the ratio of the Net Disbursements (current US$) in Congo (Republic) in 2010 to that in 2011?
Your response must be concise. 0.8. What is the ratio of the Net Disbursements (current US$) of Middle East & North Africa (all income levels) in 2010 to that in 2012?
Provide a short and direct response. 0.42. What is the ratio of the Net Disbursements (current US$) in Pakistan in 2010 to that in 2012?
Your response must be concise. 0.53. What is the ratio of the Net Disbursements (current US$) in Middle East & North Africa (all income levels) in 2010 to that in 2013?
Offer a terse response. 0.29. What is the ratio of the Net Disbursements (current US$) of Angola in 2010 to that in 2013?
Offer a terse response. 0.03. What is the ratio of the Net Disbursements (current US$) in Congo (Republic) in 2010 to that in 2013?
Provide a short and direct response. 0.67. What is the ratio of the Net Disbursements (current US$) of Pakistan in 2010 to that in 2013?
Offer a terse response. 2.5. What is the ratio of the Net Disbursements (current US$) in Middle East & North Africa (all income levels) in 2011 to that in 2012?
Your answer should be very brief. 0.57. What is the ratio of the Net Disbursements (current US$) in Pakistan in 2011 to that in 2012?
Offer a terse response. 0.32. What is the ratio of the Net Disbursements (current US$) in Middle East & North Africa (all income levels) in 2011 to that in 2013?
Your response must be concise. 0.4. What is the ratio of the Net Disbursements (current US$) of Pakistan in 2011 to that in 2013?
Your answer should be very brief. 1.5. What is the ratio of the Net Disbursements (current US$) of Middle East & North Africa (all income levels) in 2012 to that in 2013?
Provide a succinct answer. 0.69. What is the ratio of the Net Disbursements (current US$) of Congo (Republic) in 2012 to that in 2013?
Your answer should be compact. 0.33. What is the ratio of the Net Disbursements (current US$) in Pakistan in 2012 to that in 2013?
Provide a short and direct response. 4.75. What is the difference between the highest and the second highest Net Disbursements (current US$) in Middle East & North Africa (all income levels)?
Your answer should be compact. 1.21e+06. What is the difference between the highest and the second highest Net Disbursements (current US$) of Angola?
Make the answer very short. 5.19e+07. What is the difference between the highest and the second highest Net Disbursements (current US$) in Pakistan?
Make the answer very short. 2.90e+05. What is the difference between the highest and the lowest Net Disbursements (current US$) of Middle East & North Africa (all income levels)?
Provide a succinct answer. 3.92e+06. What is the difference between the highest and the lowest Net Disbursements (current US$) of Angola?
Ensure brevity in your answer.  9.24e+07. What is the difference between the highest and the lowest Net Disbursements (current US$) of Congo (Republic)?
Make the answer very short. 9.00e+04. 